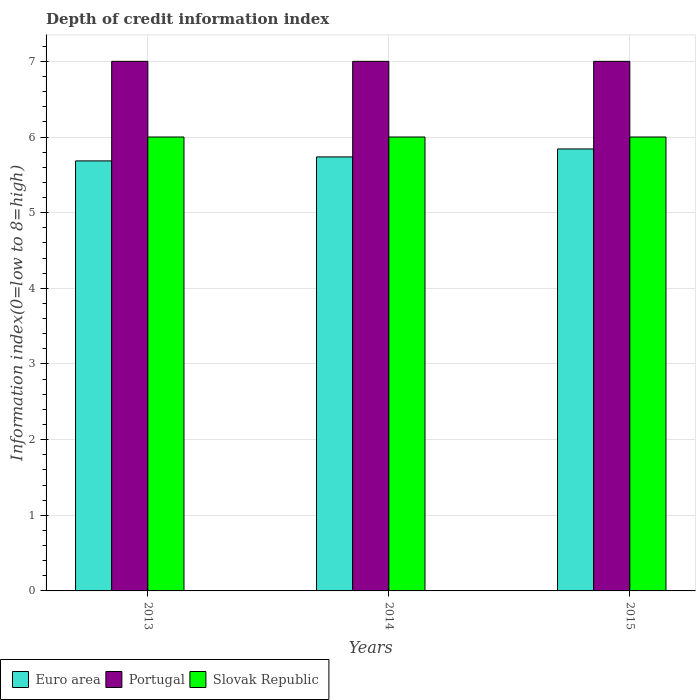How many groups of bars are there?
Provide a succinct answer. 3. Are the number of bars on each tick of the X-axis equal?
Your answer should be very brief. Yes. How many bars are there on the 3rd tick from the left?
Ensure brevity in your answer.  3. How many bars are there on the 2nd tick from the right?
Give a very brief answer. 3. What is the information index in Euro area in 2014?
Your response must be concise. 5.74. Across all years, what is the minimum information index in Portugal?
Your answer should be very brief. 7. In which year was the information index in Portugal maximum?
Your answer should be very brief. 2013. In which year was the information index in Slovak Republic minimum?
Offer a terse response. 2013. What is the total information index in Portugal in the graph?
Offer a very short reply. 21. What is the difference between the information index in Portugal in 2015 and the information index in Euro area in 2013?
Offer a terse response. 1.32. What is the average information index in Euro area per year?
Offer a very short reply. 5.75. In the year 2014, what is the difference between the information index in Euro area and information index in Slovak Republic?
Make the answer very short. -0.26. What is the ratio of the information index in Portugal in 2014 to that in 2015?
Ensure brevity in your answer.  1. Is the information index in Portugal in 2014 less than that in 2015?
Keep it short and to the point. No. What is the difference between the highest and the lowest information index in Euro area?
Offer a terse response. 0.16. In how many years, is the information index in Slovak Republic greater than the average information index in Slovak Republic taken over all years?
Your answer should be very brief. 0. Is the sum of the information index in Slovak Republic in 2013 and 2014 greater than the maximum information index in Euro area across all years?
Provide a succinct answer. Yes. What does the 1st bar from the right in 2014 represents?
Give a very brief answer. Slovak Republic. Is it the case that in every year, the sum of the information index in Euro area and information index in Slovak Republic is greater than the information index in Portugal?
Your response must be concise. Yes. Are all the bars in the graph horizontal?
Your response must be concise. No. What is the difference between two consecutive major ticks on the Y-axis?
Provide a succinct answer. 1. Are the values on the major ticks of Y-axis written in scientific E-notation?
Offer a terse response. No. Does the graph contain grids?
Offer a very short reply. Yes. Where does the legend appear in the graph?
Your answer should be compact. Bottom left. How are the legend labels stacked?
Your response must be concise. Horizontal. What is the title of the graph?
Ensure brevity in your answer.  Depth of credit information index. Does "Nicaragua" appear as one of the legend labels in the graph?
Make the answer very short. No. What is the label or title of the X-axis?
Give a very brief answer. Years. What is the label or title of the Y-axis?
Your answer should be compact. Information index(0=low to 8=high). What is the Information index(0=low to 8=high) in Euro area in 2013?
Keep it short and to the point. 5.68. What is the Information index(0=low to 8=high) of Euro area in 2014?
Ensure brevity in your answer.  5.74. What is the Information index(0=low to 8=high) in Euro area in 2015?
Make the answer very short. 5.84. What is the Information index(0=low to 8=high) of Portugal in 2015?
Ensure brevity in your answer.  7. What is the Information index(0=low to 8=high) in Slovak Republic in 2015?
Make the answer very short. 6. Across all years, what is the maximum Information index(0=low to 8=high) of Euro area?
Provide a succinct answer. 5.84. Across all years, what is the maximum Information index(0=low to 8=high) in Portugal?
Your answer should be compact. 7. Across all years, what is the maximum Information index(0=low to 8=high) in Slovak Republic?
Your response must be concise. 6. Across all years, what is the minimum Information index(0=low to 8=high) of Euro area?
Provide a short and direct response. 5.68. What is the total Information index(0=low to 8=high) of Euro area in the graph?
Provide a succinct answer. 17.26. What is the difference between the Information index(0=low to 8=high) of Euro area in 2013 and that in 2014?
Give a very brief answer. -0.05. What is the difference between the Information index(0=low to 8=high) in Portugal in 2013 and that in 2014?
Keep it short and to the point. 0. What is the difference between the Information index(0=low to 8=high) in Slovak Republic in 2013 and that in 2014?
Offer a terse response. 0. What is the difference between the Information index(0=low to 8=high) in Euro area in 2013 and that in 2015?
Your answer should be compact. -0.16. What is the difference between the Information index(0=low to 8=high) in Euro area in 2014 and that in 2015?
Your response must be concise. -0.11. What is the difference between the Information index(0=low to 8=high) in Euro area in 2013 and the Information index(0=low to 8=high) in Portugal in 2014?
Give a very brief answer. -1.32. What is the difference between the Information index(0=low to 8=high) in Euro area in 2013 and the Information index(0=low to 8=high) in Slovak Republic in 2014?
Your answer should be very brief. -0.32. What is the difference between the Information index(0=low to 8=high) in Portugal in 2013 and the Information index(0=low to 8=high) in Slovak Republic in 2014?
Offer a terse response. 1. What is the difference between the Information index(0=low to 8=high) in Euro area in 2013 and the Information index(0=low to 8=high) in Portugal in 2015?
Ensure brevity in your answer.  -1.32. What is the difference between the Information index(0=low to 8=high) in Euro area in 2013 and the Information index(0=low to 8=high) in Slovak Republic in 2015?
Your answer should be compact. -0.32. What is the difference between the Information index(0=low to 8=high) in Portugal in 2013 and the Information index(0=low to 8=high) in Slovak Republic in 2015?
Your answer should be compact. 1. What is the difference between the Information index(0=low to 8=high) in Euro area in 2014 and the Information index(0=low to 8=high) in Portugal in 2015?
Your answer should be compact. -1.26. What is the difference between the Information index(0=low to 8=high) of Euro area in 2014 and the Information index(0=low to 8=high) of Slovak Republic in 2015?
Your response must be concise. -0.26. What is the difference between the Information index(0=low to 8=high) in Portugal in 2014 and the Information index(0=low to 8=high) in Slovak Republic in 2015?
Your answer should be very brief. 1. What is the average Information index(0=low to 8=high) in Euro area per year?
Ensure brevity in your answer.  5.75. What is the average Information index(0=low to 8=high) in Slovak Republic per year?
Provide a succinct answer. 6. In the year 2013, what is the difference between the Information index(0=low to 8=high) in Euro area and Information index(0=low to 8=high) in Portugal?
Make the answer very short. -1.32. In the year 2013, what is the difference between the Information index(0=low to 8=high) of Euro area and Information index(0=low to 8=high) of Slovak Republic?
Ensure brevity in your answer.  -0.32. In the year 2014, what is the difference between the Information index(0=low to 8=high) of Euro area and Information index(0=low to 8=high) of Portugal?
Make the answer very short. -1.26. In the year 2014, what is the difference between the Information index(0=low to 8=high) of Euro area and Information index(0=low to 8=high) of Slovak Republic?
Make the answer very short. -0.26. In the year 2015, what is the difference between the Information index(0=low to 8=high) of Euro area and Information index(0=low to 8=high) of Portugal?
Provide a succinct answer. -1.16. In the year 2015, what is the difference between the Information index(0=low to 8=high) of Euro area and Information index(0=low to 8=high) of Slovak Republic?
Provide a short and direct response. -0.16. In the year 2015, what is the difference between the Information index(0=low to 8=high) in Portugal and Information index(0=low to 8=high) in Slovak Republic?
Your response must be concise. 1. What is the ratio of the Information index(0=low to 8=high) in Slovak Republic in 2013 to that in 2014?
Ensure brevity in your answer.  1. What is the ratio of the Information index(0=low to 8=high) of Euro area in 2013 to that in 2015?
Offer a very short reply. 0.97. What is the ratio of the Information index(0=low to 8=high) of Slovak Republic in 2014 to that in 2015?
Offer a terse response. 1. What is the difference between the highest and the second highest Information index(0=low to 8=high) in Euro area?
Provide a succinct answer. 0.11. What is the difference between the highest and the second highest Information index(0=low to 8=high) of Portugal?
Offer a terse response. 0. What is the difference between the highest and the lowest Information index(0=low to 8=high) of Euro area?
Offer a very short reply. 0.16. 